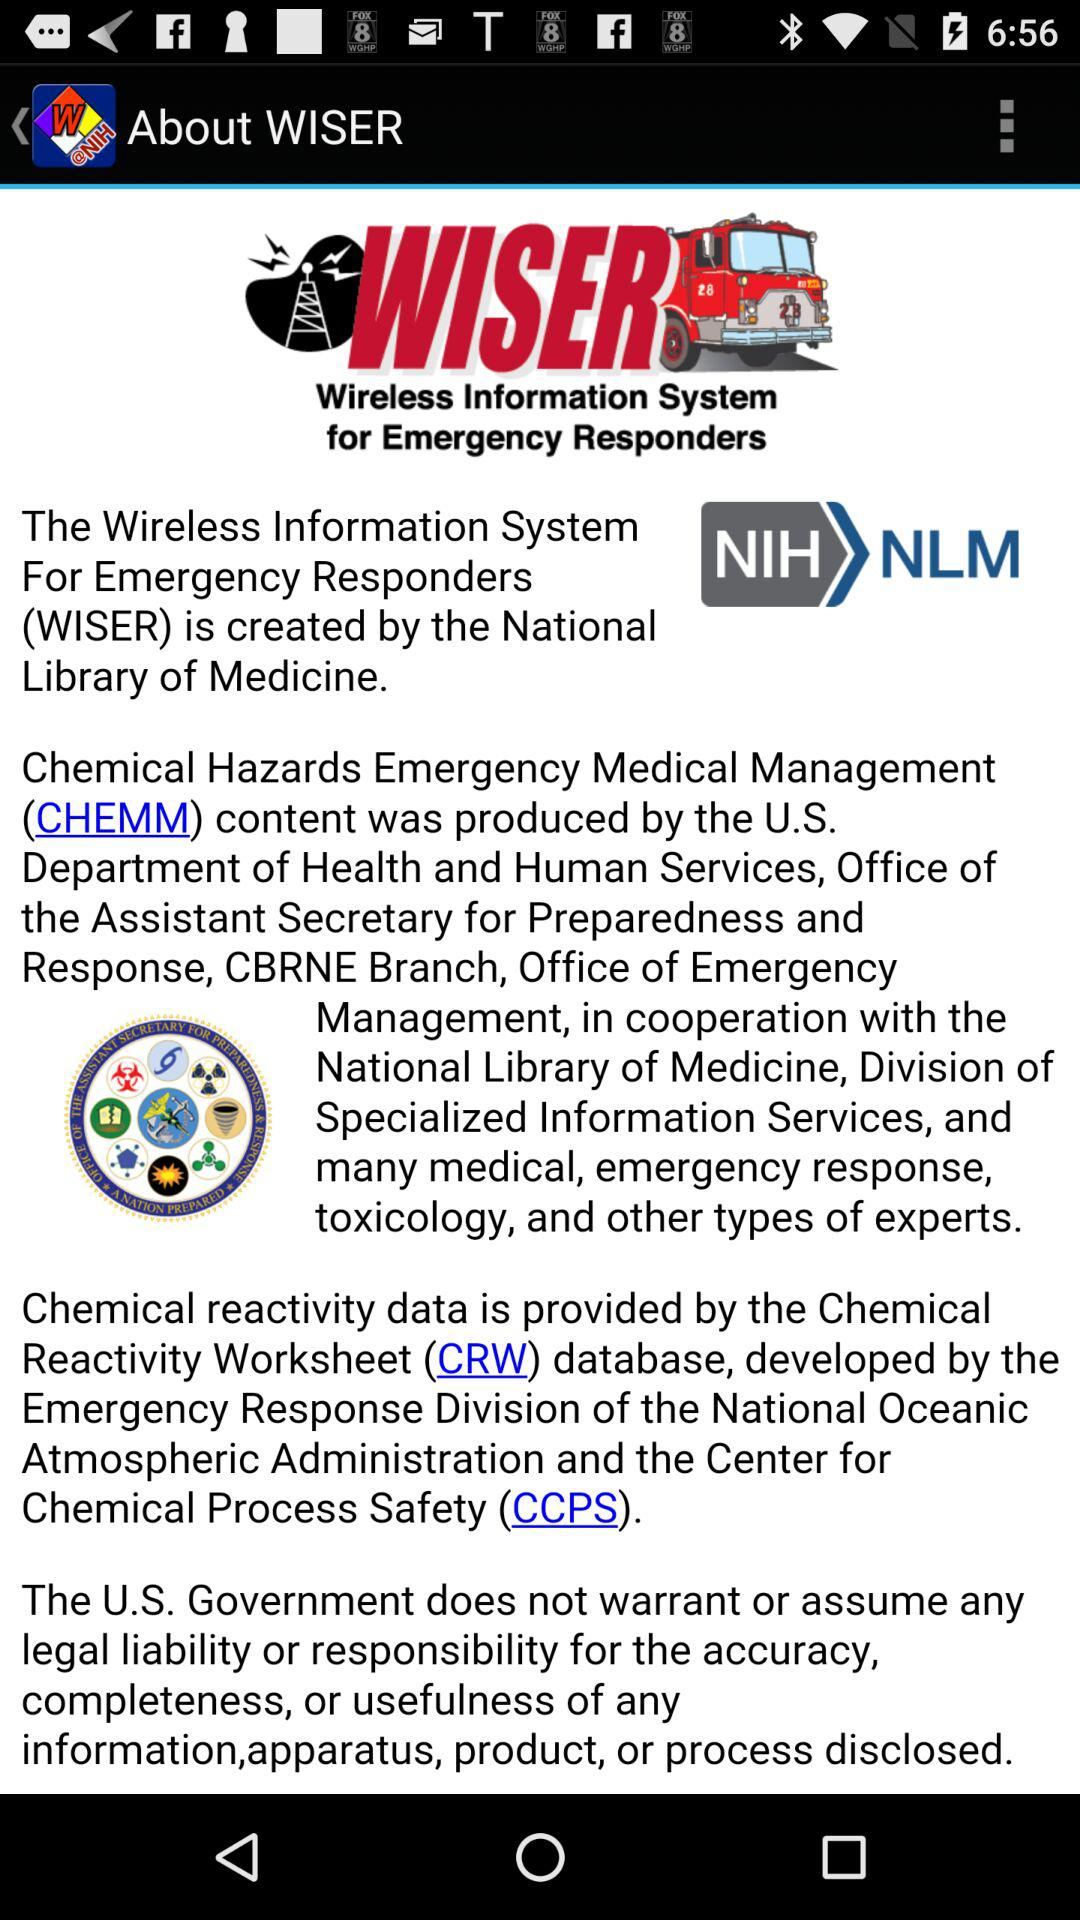Who created the wireless information system for emergency responders? The wireless information system for emergency responders is created by the "National Library of Medicine". 